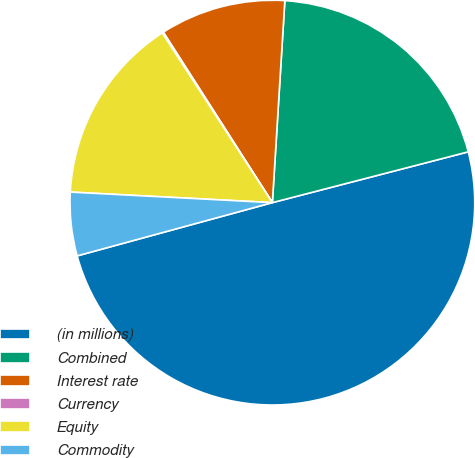Convert chart. <chart><loc_0><loc_0><loc_500><loc_500><pie_chart><fcel>(in millions)<fcel>Combined<fcel>Interest rate<fcel>Currency<fcel>Equity<fcel>Commodity<nl><fcel>49.8%<fcel>19.98%<fcel>10.04%<fcel>0.1%<fcel>15.01%<fcel>5.07%<nl></chart> 